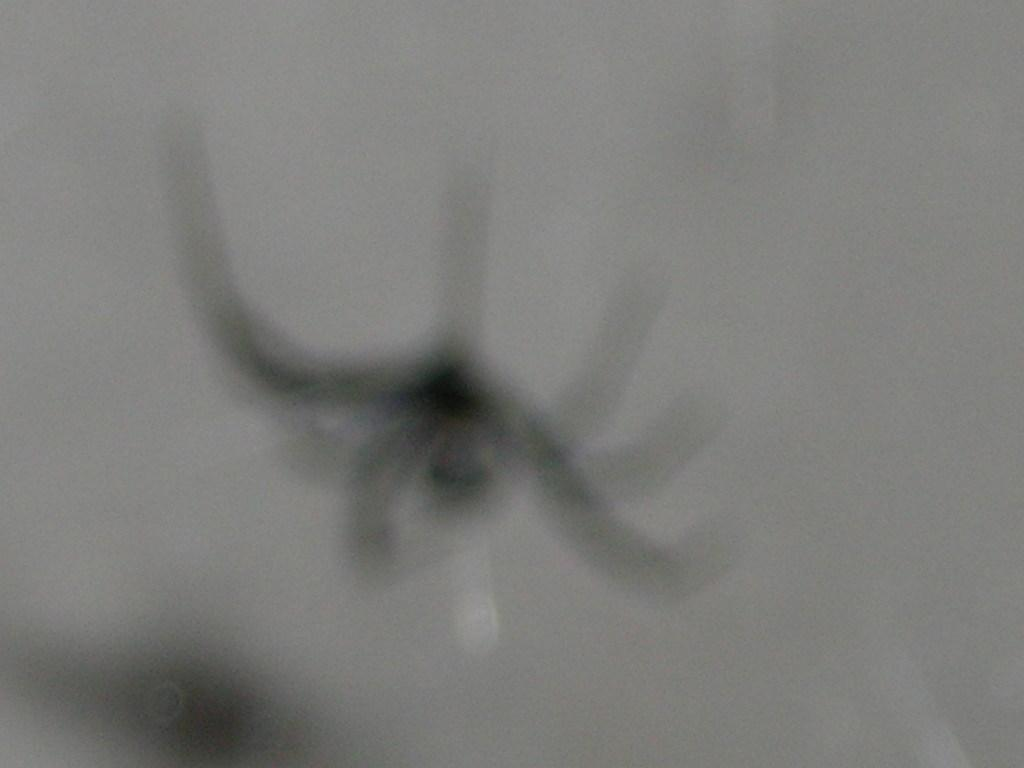What is the main subject of the image? The main subject of the image is a spider. What is the color of the spider? The spider is black in color. What is the color of the background in the image? The background of the image is white. What type of curtain can be seen hanging from the spider's legs in the image? There is no curtain present in the image, and the spider's legs do not have any curtains hanging from them. What type of trousers is the spider wearing in the image? Spiders do not wear trousers, so this question cannot be answered definitively from the image. 